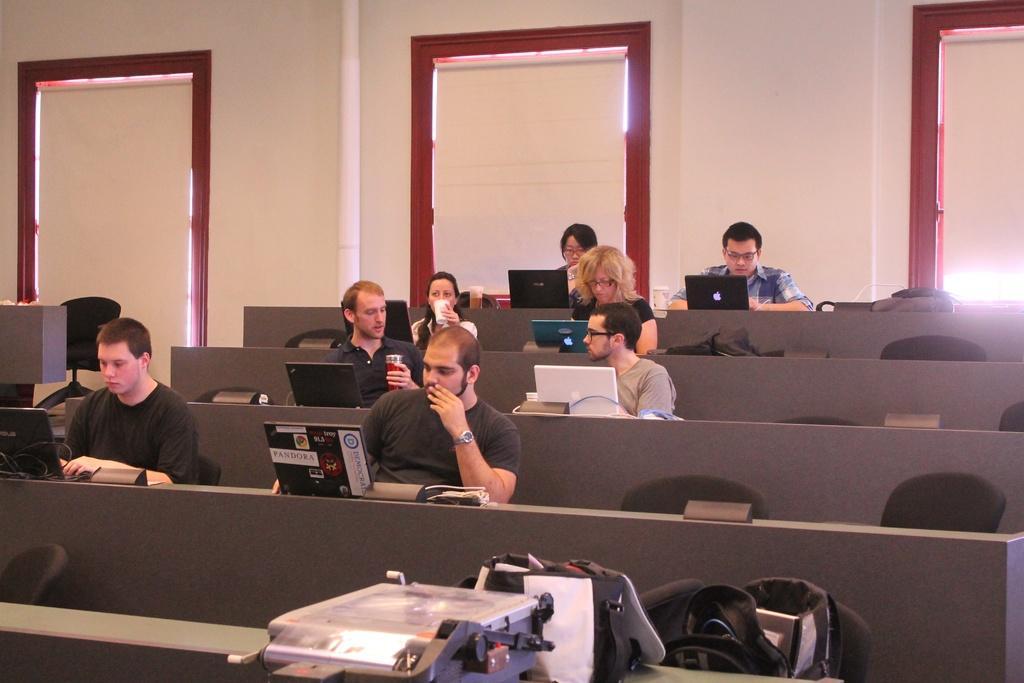Describe this image in one or two sentences. There are few people sitting on the chairs. I can see the laptops and few other things, which are placed on the desks. This looks like a machine and a bag, which are placed on the table. I can see another bag on the chair. This looks like a pipe, which is attached to the wall. 